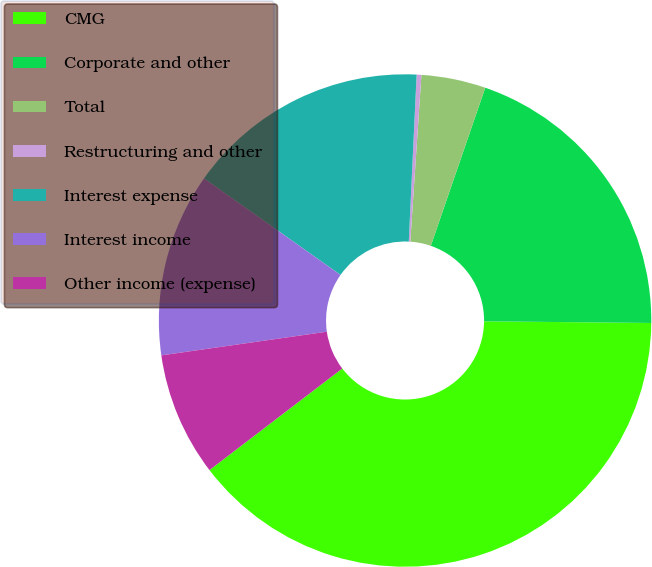<chart> <loc_0><loc_0><loc_500><loc_500><pie_chart><fcel>CMG<fcel>Corporate and other<fcel>Total<fcel>Restructuring and other<fcel>Interest expense<fcel>Interest income<fcel>Other income (expense)<nl><fcel>39.45%<fcel>19.88%<fcel>4.22%<fcel>0.31%<fcel>15.96%<fcel>12.05%<fcel>8.13%<nl></chart> 